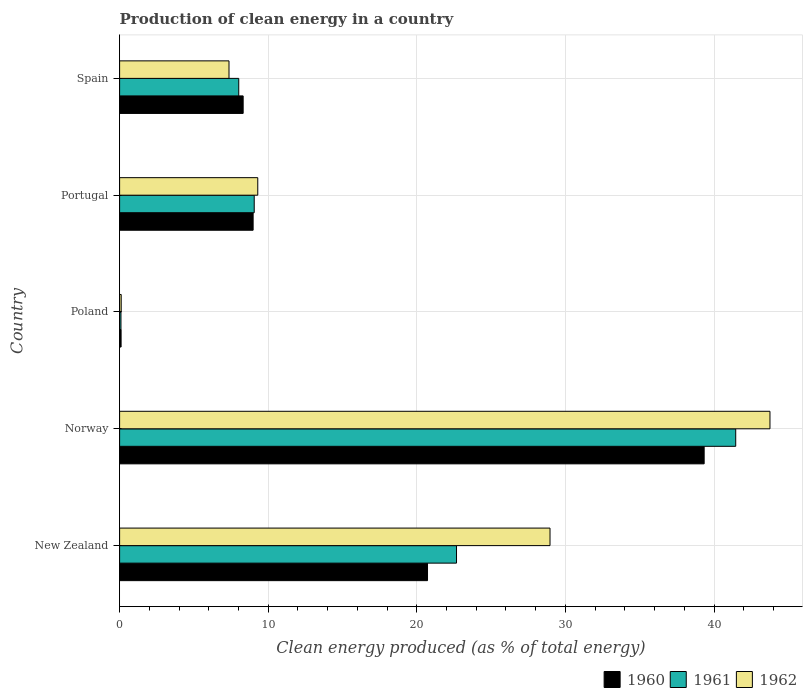How many different coloured bars are there?
Your response must be concise. 3. Are the number of bars on each tick of the Y-axis equal?
Keep it short and to the point. Yes. What is the label of the 3rd group of bars from the top?
Provide a short and direct response. Poland. What is the percentage of clean energy produced in 1962 in New Zealand?
Provide a short and direct response. 28.96. Across all countries, what is the maximum percentage of clean energy produced in 1960?
Provide a succinct answer. 39.34. Across all countries, what is the minimum percentage of clean energy produced in 1962?
Give a very brief answer. 0.11. In which country was the percentage of clean energy produced in 1962 minimum?
Provide a short and direct response. Poland. What is the total percentage of clean energy produced in 1960 in the graph?
Ensure brevity in your answer.  77.46. What is the difference between the percentage of clean energy produced in 1962 in Norway and that in Portugal?
Ensure brevity in your answer.  34.47. What is the difference between the percentage of clean energy produced in 1961 in Poland and the percentage of clean energy produced in 1962 in Spain?
Keep it short and to the point. -7.27. What is the average percentage of clean energy produced in 1962 per country?
Make the answer very short. 17.9. What is the difference between the percentage of clean energy produced in 1961 and percentage of clean energy produced in 1962 in Spain?
Ensure brevity in your answer.  0.66. What is the ratio of the percentage of clean energy produced in 1961 in New Zealand to that in Poland?
Provide a succinct answer. 247.72. Is the percentage of clean energy produced in 1962 in New Zealand less than that in Norway?
Keep it short and to the point. Yes. What is the difference between the highest and the second highest percentage of clean energy produced in 1960?
Keep it short and to the point. 18.62. What is the difference between the highest and the lowest percentage of clean energy produced in 1962?
Keep it short and to the point. 43.66. In how many countries, is the percentage of clean energy produced in 1962 greater than the average percentage of clean energy produced in 1962 taken over all countries?
Provide a short and direct response. 2. Is the sum of the percentage of clean energy produced in 1962 in Poland and Spain greater than the maximum percentage of clean energy produced in 1960 across all countries?
Your response must be concise. No. What does the 1st bar from the top in Portugal represents?
Make the answer very short. 1962. What does the 2nd bar from the bottom in New Zealand represents?
Your answer should be compact. 1961. How many bars are there?
Make the answer very short. 15. How many countries are there in the graph?
Provide a short and direct response. 5. What is the difference between two consecutive major ticks on the X-axis?
Provide a short and direct response. 10. Are the values on the major ticks of X-axis written in scientific E-notation?
Offer a very short reply. No. Where does the legend appear in the graph?
Ensure brevity in your answer.  Bottom right. How are the legend labels stacked?
Provide a short and direct response. Horizontal. What is the title of the graph?
Your answer should be very brief. Production of clean energy in a country. What is the label or title of the X-axis?
Make the answer very short. Clean energy produced (as % of total energy). What is the Clean energy produced (as % of total energy) of 1960 in New Zealand?
Provide a short and direct response. 20.72. What is the Clean energy produced (as % of total energy) in 1961 in New Zealand?
Your answer should be very brief. 22.67. What is the Clean energy produced (as % of total energy) of 1962 in New Zealand?
Your response must be concise. 28.96. What is the Clean energy produced (as % of total energy) of 1960 in Norway?
Offer a very short reply. 39.34. What is the Clean energy produced (as % of total energy) of 1961 in Norway?
Your response must be concise. 41.46. What is the Clean energy produced (as % of total energy) of 1962 in Norway?
Your answer should be compact. 43.77. What is the Clean energy produced (as % of total energy) in 1960 in Poland?
Your answer should be very brief. 0.1. What is the Clean energy produced (as % of total energy) of 1961 in Poland?
Keep it short and to the point. 0.09. What is the Clean energy produced (as % of total energy) in 1962 in Poland?
Ensure brevity in your answer.  0.11. What is the Clean energy produced (as % of total energy) of 1960 in Portugal?
Your answer should be compact. 8.99. What is the Clean energy produced (as % of total energy) of 1961 in Portugal?
Give a very brief answer. 9.06. What is the Clean energy produced (as % of total energy) of 1962 in Portugal?
Ensure brevity in your answer.  9.3. What is the Clean energy produced (as % of total energy) of 1960 in Spain?
Provide a short and direct response. 8.31. What is the Clean energy produced (as % of total energy) in 1961 in Spain?
Provide a short and direct response. 8.02. What is the Clean energy produced (as % of total energy) of 1962 in Spain?
Provide a succinct answer. 7.36. Across all countries, what is the maximum Clean energy produced (as % of total energy) of 1960?
Offer a terse response. 39.34. Across all countries, what is the maximum Clean energy produced (as % of total energy) of 1961?
Give a very brief answer. 41.46. Across all countries, what is the maximum Clean energy produced (as % of total energy) in 1962?
Your answer should be compact. 43.77. Across all countries, what is the minimum Clean energy produced (as % of total energy) of 1960?
Give a very brief answer. 0.1. Across all countries, what is the minimum Clean energy produced (as % of total energy) of 1961?
Provide a succinct answer. 0.09. Across all countries, what is the minimum Clean energy produced (as % of total energy) of 1962?
Offer a very short reply. 0.11. What is the total Clean energy produced (as % of total energy) of 1960 in the graph?
Provide a short and direct response. 77.46. What is the total Clean energy produced (as % of total energy) in 1961 in the graph?
Offer a very short reply. 81.3. What is the total Clean energy produced (as % of total energy) of 1962 in the graph?
Ensure brevity in your answer.  89.5. What is the difference between the Clean energy produced (as % of total energy) in 1960 in New Zealand and that in Norway?
Keep it short and to the point. -18.62. What is the difference between the Clean energy produced (as % of total energy) in 1961 in New Zealand and that in Norway?
Offer a terse response. -18.79. What is the difference between the Clean energy produced (as % of total energy) in 1962 in New Zealand and that in Norway?
Offer a very short reply. -14.8. What is the difference between the Clean energy produced (as % of total energy) of 1960 in New Zealand and that in Poland?
Ensure brevity in your answer.  20.62. What is the difference between the Clean energy produced (as % of total energy) of 1961 in New Zealand and that in Poland?
Make the answer very short. 22.58. What is the difference between the Clean energy produced (as % of total energy) in 1962 in New Zealand and that in Poland?
Keep it short and to the point. 28.86. What is the difference between the Clean energy produced (as % of total energy) of 1960 in New Zealand and that in Portugal?
Offer a very short reply. 11.74. What is the difference between the Clean energy produced (as % of total energy) in 1961 in New Zealand and that in Portugal?
Offer a very short reply. 13.61. What is the difference between the Clean energy produced (as % of total energy) of 1962 in New Zealand and that in Portugal?
Make the answer very short. 19.67. What is the difference between the Clean energy produced (as % of total energy) of 1960 in New Zealand and that in Spain?
Keep it short and to the point. 12.41. What is the difference between the Clean energy produced (as % of total energy) of 1961 in New Zealand and that in Spain?
Keep it short and to the point. 14.65. What is the difference between the Clean energy produced (as % of total energy) of 1962 in New Zealand and that in Spain?
Provide a short and direct response. 21.6. What is the difference between the Clean energy produced (as % of total energy) of 1960 in Norway and that in Poland?
Give a very brief answer. 39.24. What is the difference between the Clean energy produced (as % of total energy) of 1961 in Norway and that in Poland?
Provide a short and direct response. 41.37. What is the difference between the Clean energy produced (as % of total energy) in 1962 in Norway and that in Poland?
Ensure brevity in your answer.  43.66. What is the difference between the Clean energy produced (as % of total energy) of 1960 in Norway and that in Portugal?
Offer a terse response. 30.35. What is the difference between the Clean energy produced (as % of total energy) of 1961 in Norway and that in Portugal?
Provide a succinct answer. 32.4. What is the difference between the Clean energy produced (as % of total energy) in 1962 in Norway and that in Portugal?
Ensure brevity in your answer.  34.47. What is the difference between the Clean energy produced (as % of total energy) in 1960 in Norway and that in Spain?
Ensure brevity in your answer.  31.02. What is the difference between the Clean energy produced (as % of total energy) of 1961 in Norway and that in Spain?
Provide a short and direct response. 33.44. What is the difference between the Clean energy produced (as % of total energy) of 1962 in Norway and that in Spain?
Make the answer very short. 36.4. What is the difference between the Clean energy produced (as % of total energy) of 1960 in Poland and that in Portugal?
Ensure brevity in your answer.  -8.88. What is the difference between the Clean energy produced (as % of total energy) in 1961 in Poland and that in Portugal?
Make the answer very short. -8.97. What is the difference between the Clean energy produced (as % of total energy) of 1962 in Poland and that in Portugal?
Give a very brief answer. -9.19. What is the difference between the Clean energy produced (as % of total energy) of 1960 in Poland and that in Spain?
Provide a short and direct response. -8.21. What is the difference between the Clean energy produced (as % of total energy) in 1961 in Poland and that in Spain?
Keep it short and to the point. -7.93. What is the difference between the Clean energy produced (as % of total energy) of 1962 in Poland and that in Spain?
Offer a very short reply. -7.25. What is the difference between the Clean energy produced (as % of total energy) of 1960 in Portugal and that in Spain?
Offer a very short reply. 0.67. What is the difference between the Clean energy produced (as % of total energy) of 1961 in Portugal and that in Spain?
Offer a terse response. 1.04. What is the difference between the Clean energy produced (as % of total energy) in 1962 in Portugal and that in Spain?
Give a very brief answer. 1.94. What is the difference between the Clean energy produced (as % of total energy) of 1960 in New Zealand and the Clean energy produced (as % of total energy) of 1961 in Norway?
Keep it short and to the point. -20.74. What is the difference between the Clean energy produced (as % of total energy) in 1960 in New Zealand and the Clean energy produced (as % of total energy) in 1962 in Norway?
Keep it short and to the point. -23.05. What is the difference between the Clean energy produced (as % of total energy) of 1961 in New Zealand and the Clean energy produced (as % of total energy) of 1962 in Norway?
Provide a short and direct response. -21.09. What is the difference between the Clean energy produced (as % of total energy) of 1960 in New Zealand and the Clean energy produced (as % of total energy) of 1961 in Poland?
Make the answer very short. 20.63. What is the difference between the Clean energy produced (as % of total energy) of 1960 in New Zealand and the Clean energy produced (as % of total energy) of 1962 in Poland?
Offer a very short reply. 20.61. What is the difference between the Clean energy produced (as % of total energy) in 1961 in New Zealand and the Clean energy produced (as % of total energy) in 1962 in Poland?
Your response must be concise. 22.56. What is the difference between the Clean energy produced (as % of total energy) in 1960 in New Zealand and the Clean energy produced (as % of total energy) in 1961 in Portugal?
Your response must be concise. 11.66. What is the difference between the Clean energy produced (as % of total energy) of 1960 in New Zealand and the Clean energy produced (as % of total energy) of 1962 in Portugal?
Provide a short and direct response. 11.42. What is the difference between the Clean energy produced (as % of total energy) of 1961 in New Zealand and the Clean energy produced (as % of total energy) of 1962 in Portugal?
Your response must be concise. 13.38. What is the difference between the Clean energy produced (as % of total energy) in 1960 in New Zealand and the Clean energy produced (as % of total energy) in 1961 in Spain?
Provide a succinct answer. 12.7. What is the difference between the Clean energy produced (as % of total energy) of 1960 in New Zealand and the Clean energy produced (as % of total energy) of 1962 in Spain?
Give a very brief answer. 13.36. What is the difference between the Clean energy produced (as % of total energy) in 1961 in New Zealand and the Clean energy produced (as % of total energy) in 1962 in Spain?
Your answer should be compact. 15.31. What is the difference between the Clean energy produced (as % of total energy) in 1960 in Norway and the Clean energy produced (as % of total energy) in 1961 in Poland?
Keep it short and to the point. 39.24. What is the difference between the Clean energy produced (as % of total energy) in 1960 in Norway and the Clean energy produced (as % of total energy) in 1962 in Poland?
Provide a short and direct response. 39.23. What is the difference between the Clean energy produced (as % of total energy) of 1961 in Norway and the Clean energy produced (as % of total energy) of 1962 in Poland?
Provide a succinct answer. 41.35. What is the difference between the Clean energy produced (as % of total energy) in 1960 in Norway and the Clean energy produced (as % of total energy) in 1961 in Portugal?
Provide a short and direct response. 30.28. What is the difference between the Clean energy produced (as % of total energy) in 1960 in Norway and the Clean energy produced (as % of total energy) in 1962 in Portugal?
Give a very brief answer. 30.04. What is the difference between the Clean energy produced (as % of total energy) of 1961 in Norway and the Clean energy produced (as % of total energy) of 1962 in Portugal?
Your answer should be very brief. 32.16. What is the difference between the Clean energy produced (as % of total energy) of 1960 in Norway and the Clean energy produced (as % of total energy) of 1961 in Spain?
Make the answer very short. 31.32. What is the difference between the Clean energy produced (as % of total energy) in 1960 in Norway and the Clean energy produced (as % of total energy) in 1962 in Spain?
Make the answer very short. 31.97. What is the difference between the Clean energy produced (as % of total energy) in 1961 in Norway and the Clean energy produced (as % of total energy) in 1962 in Spain?
Your answer should be very brief. 34.1. What is the difference between the Clean energy produced (as % of total energy) in 1960 in Poland and the Clean energy produced (as % of total energy) in 1961 in Portugal?
Give a very brief answer. -8.96. What is the difference between the Clean energy produced (as % of total energy) in 1960 in Poland and the Clean energy produced (as % of total energy) in 1962 in Portugal?
Offer a very short reply. -9.2. What is the difference between the Clean energy produced (as % of total energy) in 1961 in Poland and the Clean energy produced (as % of total energy) in 1962 in Portugal?
Your answer should be compact. -9.21. What is the difference between the Clean energy produced (as % of total energy) of 1960 in Poland and the Clean energy produced (as % of total energy) of 1961 in Spain?
Your answer should be compact. -7.92. What is the difference between the Clean energy produced (as % of total energy) in 1960 in Poland and the Clean energy produced (as % of total energy) in 1962 in Spain?
Your answer should be compact. -7.26. What is the difference between the Clean energy produced (as % of total energy) of 1961 in Poland and the Clean energy produced (as % of total energy) of 1962 in Spain?
Keep it short and to the point. -7.27. What is the difference between the Clean energy produced (as % of total energy) in 1960 in Portugal and the Clean energy produced (as % of total energy) in 1961 in Spain?
Give a very brief answer. 0.97. What is the difference between the Clean energy produced (as % of total energy) in 1960 in Portugal and the Clean energy produced (as % of total energy) in 1962 in Spain?
Your answer should be very brief. 1.62. What is the difference between the Clean energy produced (as % of total energy) in 1961 in Portugal and the Clean energy produced (as % of total energy) in 1962 in Spain?
Make the answer very short. 1.7. What is the average Clean energy produced (as % of total energy) of 1960 per country?
Offer a terse response. 15.49. What is the average Clean energy produced (as % of total energy) of 1961 per country?
Offer a very short reply. 16.26. What is the average Clean energy produced (as % of total energy) in 1962 per country?
Your answer should be compact. 17.9. What is the difference between the Clean energy produced (as % of total energy) in 1960 and Clean energy produced (as % of total energy) in 1961 in New Zealand?
Your answer should be compact. -1.95. What is the difference between the Clean energy produced (as % of total energy) of 1960 and Clean energy produced (as % of total energy) of 1962 in New Zealand?
Provide a short and direct response. -8.24. What is the difference between the Clean energy produced (as % of total energy) in 1961 and Clean energy produced (as % of total energy) in 1962 in New Zealand?
Your response must be concise. -6.29. What is the difference between the Clean energy produced (as % of total energy) in 1960 and Clean energy produced (as % of total energy) in 1961 in Norway?
Make the answer very short. -2.12. What is the difference between the Clean energy produced (as % of total energy) of 1960 and Clean energy produced (as % of total energy) of 1962 in Norway?
Provide a succinct answer. -4.43. What is the difference between the Clean energy produced (as % of total energy) in 1961 and Clean energy produced (as % of total energy) in 1962 in Norway?
Your answer should be very brief. -2.31. What is the difference between the Clean energy produced (as % of total energy) of 1960 and Clean energy produced (as % of total energy) of 1961 in Poland?
Offer a terse response. 0.01. What is the difference between the Clean energy produced (as % of total energy) of 1960 and Clean energy produced (as % of total energy) of 1962 in Poland?
Give a very brief answer. -0.01. What is the difference between the Clean energy produced (as % of total energy) of 1961 and Clean energy produced (as % of total energy) of 1962 in Poland?
Offer a terse response. -0.02. What is the difference between the Clean energy produced (as % of total energy) of 1960 and Clean energy produced (as % of total energy) of 1961 in Portugal?
Make the answer very short. -0.07. What is the difference between the Clean energy produced (as % of total energy) of 1960 and Clean energy produced (as % of total energy) of 1962 in Portugal?
Offer a terse response. -0.31. What is the difference between the Clean energy produced (as % of total energy) of 1961 and Clean energy produced (as % of total energy) of 1962 in Portugal?
Offer a very short reply. -0.24. What is the difference between the Clean energy produced (as % of total energy) in 1960 and Clean energy produced (as % of total energy) in 1961 in Spain?
Give a very brief answer. 0.3. What is the difference between the Clean energy produced (as % of total energy) of 1960 and Clean energy produced (as % of total energy) of 1962 in Spain?
Your answer should be very brief. 0.95. What is the difference between the Clean energy produced (as % of total energy) of 1961 and Clean energy produced (as % of total energy) of 1962 in Spain?
Your answer should be compact. 0.66. What is the ratio of the Clean energy produced (as % of total energy) of 1960 in New Zealand to that in Norway?
Offer a very short reply. 0.53. What is the ratio of the Clean energy produced (as % of total energy) of 1961 in New Zealand to that in Norway?
Make the answer very short. 0.55. What is the ratio of the Clean energy produced (as % of total energy) in 1962 in New Zealand to that in Norway?
Provide a succinct answer. 0.66. What is the ratio of the Clean energy produced (as % of total energy) of 1960 in New Zealand to that in Poland?
Your answer should be compact. 206.53. What is the ratio of the Clean energy produced (as % of total energy) of 1961 in New Zealand to that in Poland?
Your response must be concise. 247.72. What is the ratio of the Clean energy produced (as % of total energy) of 1962 in New Zealand to that in Poland?
Keep it short and to the point. 267.62. What is the ratio of the Clean energy produced (as % of total energy) of 1960 in New Zealand to that in Portugal?
Ensure brevity in your answer.  2.31. What is the ratio of the Clean energy produced (as % of total energy) of 1961 in New Zealand to that in Portugal?
Offer a terse response. 2.5. What is the ratio of the Clean energy produced (as % of total energy) in 1962 in New Zealand to that in Portugal?
Make the answer very short. 3.12. What is the ratio of the Clean energy produced (as % of total energy) in 1960 in New Zealand to that in Spain?
Your answer should be very brief. 2.49. What is the ratio of the Clean energy produced (as % of total energy) in 1961 in New Zealand to that in Spain?
Give a very brief answer. 2.83. What is the ratio of the Clean energy produced (as % of total energy) of 1962 in New Zealand to that in Spain?
Keep it short and to the point. 3.93. What is the ratio of the Clean energy produced (as % of total energy) in 1960 in Norway to that in Poland?
Give a very brief answer. 392.08. What is the ratio of the Clean energy produced (as % of total energy) of 1961 in Norway to that in Poland?
Ensure brevity in your answer.  452.99. What is the ratio of the Clean energy produced (as % of total energy) in 1962 in Norway to that in Poland?
Ensure brevity in your answer.  404.39. What is the ratio of the Clean energy produced (as % of total energy) in 1960 in Norway to that in Portugal?
Offer a very short reply. 4.38. What is the ratio of the Clean energy produced (as % of total energy) of 1961 in Norway to that in Portugal?
Your answer should be compact. 4.58. What is the ratio of the Clean energy produced (as % of total energy) in 1962 in Norway to that in Portugal?
Offer a terse response. 4.71. What is the ratio of the Clean energy produced (as % of total energy) of 1960 in Norway to that in Spain?
Provide a short and direct response. 4.73. What is the ratio of the Clean energy produced (as % of total energy) of 1961 in Norway to that in Spain?
Ensure brevity in your answer.  5.17. What is the ratio of the Clean energy produced (as % of total energy) in 1962 in Norway to that in Spain?
Keep it short and to the point. 5.94. What is the ratio of the Clean energy produced (as % of total energy) of 1960 in Poland to that in Portugal?
Give a very brief answer. 0.01. What is the ratio of the Clean energy produced (as % of total energy) in 1961 in Poland to that in Portugal?
Provide a succinct answer. 0.01. What is the ratio of the Clean energy produced (as % of total energy) of 1962 in Poland to that in Portugal?
Provide a short and direct response. 0.01. What is the ratio of the Clean energy produced (as % of total energy) of 1960 in Poland to that in Spain?
Provide a short and direct response. 0.01. What is the ratio of the Clean energy produced (as % of total energy) in 1961 in Poland to that in Spain?
Provide a succinct answer. 0.01. What is the ratio of the Clean energy produced (as % of total energy) in 1962 in Poland to that in Spain?
Give a very brief answer. 0.01. What is the ratio of the Clean energy produced (as % of total energy) of 1960 in Portugal to that in Spain?
Your answer should be compact. 1.08. What is the ratio of the Clean energy produced (as % of total energy) in 1961 in Portugal to that in Spain?
Give a very brief answer. 1.13. What is the ratio of the Clean energy produced (as % of total energy) in 1962 in Portugal to that in Spain?
Keep it short and to the point. 1.26. What is the difference between the highest and the second highest Clean energy produced (as % of total energy) in 1960?
Your answer should be compact. 18.62. What is the difference between the highest and the second highest Clean energy produced (as % of total energy) of 1961?
Make the answer very short. 18.79. What is the difference between the highest and the second highest Clean energy produced (as % of total energy) of 1962?
Ensure brevity in your answer.  14.8. What is the difference between the highest and the lowest Clean energy produced (as % of total energy) of 1960?
Your answer should be very brief. 39.24. What is the difference between the highest and the lowest Clean energy produced (as % of total energy) of 1961?
Provide a succinct answer. 41.37. What is the difference between the highest and the lowest Clean energy produced (as % of total energy) of 1962?
Offer a very short reply. 43.66. 